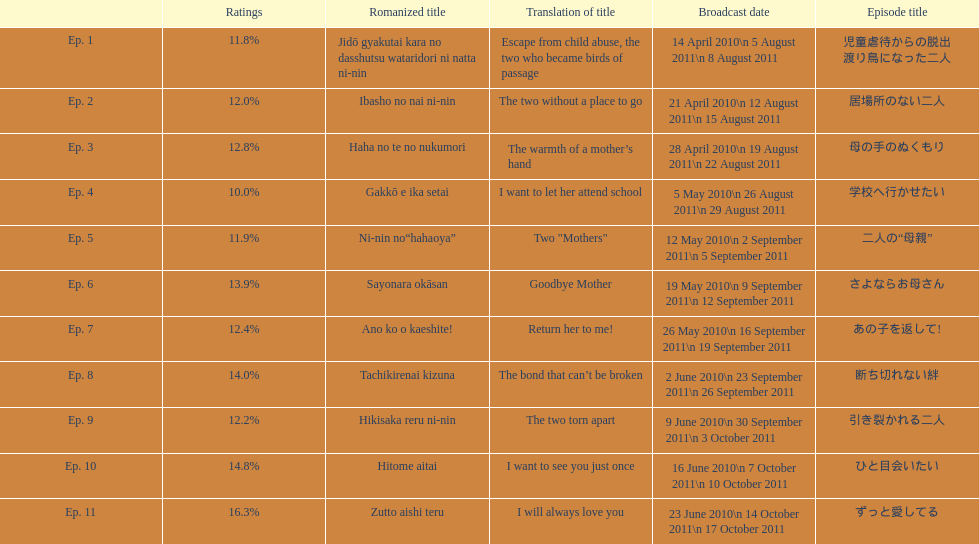How many episode total are there? 11. 